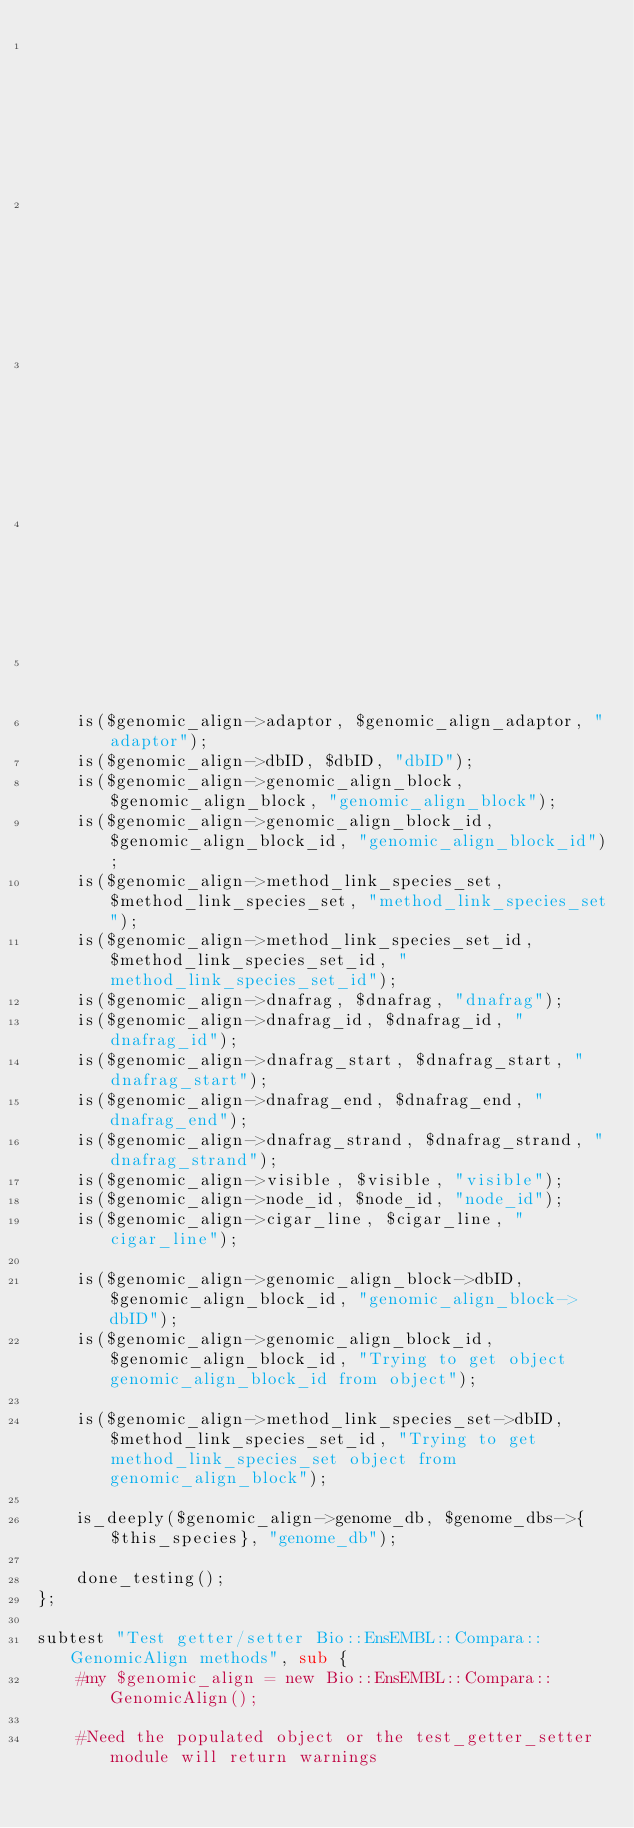<code> <loc_0><loc_0><loc_500><loc_500><_Perl_>                                                             -dnafrag_strand => $dnafrag_strand,
                                                             -visible => $visible,
                                                             -node_id => $node_id,
                                                             -cigar_line => $cigar_line
                                                            );
    is($genomic_align->adaptor, $genomic_align_adaptor, "adaptor");
    is($genomic_align->dbID, $dbID, "dbID");
    is($genomic_align->genomic_align_block, $genomic_align_block, "genomic_align_block");
    is($genomic_align->genomic_align_block_id, $genomic_align_block_id, "genomic_align_block_id");
    is($genomic_align->method_link_species_set, $method_link_species_set, "method_link_species_set");
    is($genomic_align->method_link_species_set_id, $method_link_species_set_id, "method_link_species_set_id");
    is($genomic_align->dnafrag, $dnafrag, "dnafrag");
    is($genomic_align->dnafrag_id, $dnafrag_id, "dnafrag_id");
    is($genomic_align->dnafrag_start, $dnafrag_start, "dnafrag_start");
    is($genomic_align->dnafrag_end, $dnafrag_end, "dnafrag_end");
    is($genomic_align->dnafrag_strand, $dnafrag_strand, "dnafrag_strand");
    is($genomic_align->visible, $visible, "visible");
    is($genomic_align->node_id, $node_id, "node_id");
    is($genomic_align->cigar_line, $cigar_line, "cigar_line");

    is($genomic_align->genomic_align_block->dbID, $genomic_align_block_id, "genomic_align_block->dbID");
    is($genomic_align->genomic_align_block_id, $genomic_align_block_id, "Trying to get object genomic_align_block_id from object");

    is($genomic_align->method_link_species_set->dbID, $method_link_species_set_id, "Trying to get method_link_species_set object from genomic_align_block");
    
    is_deeply($genomic_align->genome_db, $genome_dbs->{$this_species}, "genome_db");

    done_testing();
};

subtest "Test getter/setter Bio::EnsEMBL::Compara::GenomicAlign methods", sub {
    #my $genomic_align = new Bio::EnsEMBL::Compara::GenomicAlign();

    #Need the populated object or the test_getter_setter module will return warnings </code> 